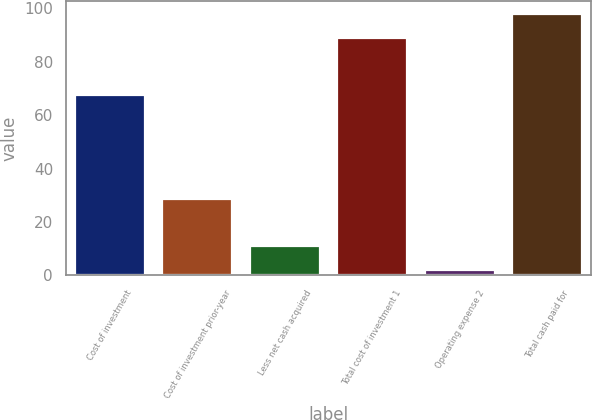Convert chart. <chart><loc_0><loc_0><loc_500><loc_500><bar_chart><fcel>Cost of investment<fcel>Cost of investment prior-year<fcel>Less net cash acquired<fcel>Total cost of investment 1<fcel>Operating expense 2<fcel>Total cash paid for<nl><fcel>67.7<fcel>28.5<fcel>10.91<fcel>89.1<fcel>2<fcel>98.01<nl></chart> 